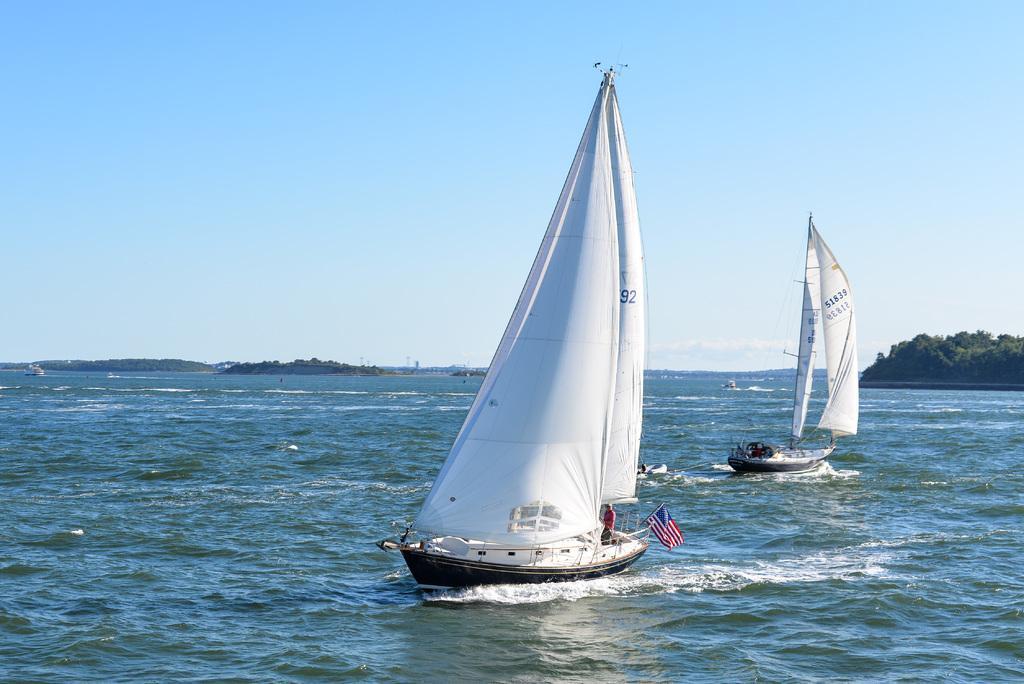Describe this image in one or two sentences. In this picture there are two ships. At the bottom there is a man who is standing near to the railing and flag. In the background I can see the ocean. On the right I can see many trees on the land. At the top I can see the sky. 